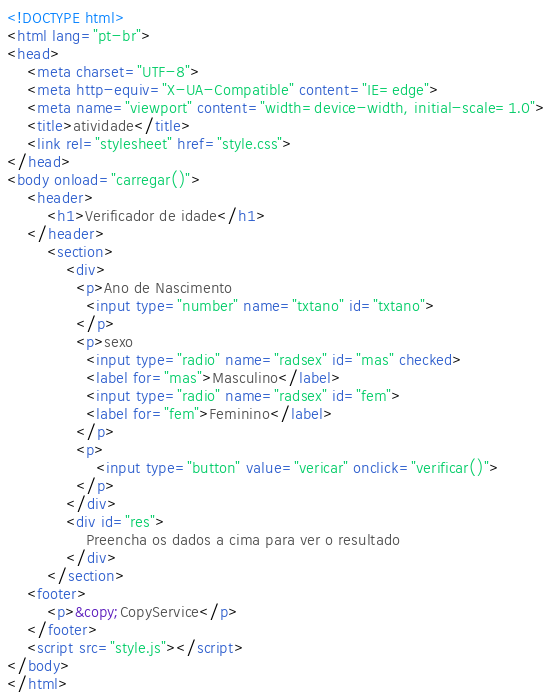Convert code to text. <code><loc_0><loc_0><loc_500><loc_500><_HTML_><!DOCTYPE html>
<html lang="pt-br">
<head>
    <meta charset="UTF-8">
    <meta http-equiv="X-UA-Compatible" content="IE=edge">
    <meta name="viewport" content="width=device-width, initial-scale=1.0">
    <title>atividade</title>
    <link rel="stylesheet" href="style.css">
</head>
<body onload="carregar()">
    <header>
        <h1>Verificador de idade</h1>
    </header>
        <section>
            <div>
              <p>Ano de Nascimento
                <input type="number" name="txtano" id="txtano">
              </p>  
              <p>sexo
                <input type="radio" name="radsex" id="mas" checked>
                <label for="mas">Masculino</label>
                <input type="radio" name="radsex" id="fem">
                <label for="fem">Feminino</label>
              </p>
              <p>
                  <input type="button" value="vericar" onclick="verificar()">
              </p>
            </div>
            <div id="res">
                Preencha os dados a cima para ver o resultado
            </div>
        </section>
    <footer>
        <p>&copy;CopyService</p>
    </footer>
    <script src="style.js"></script>
</body>
</html></code> 